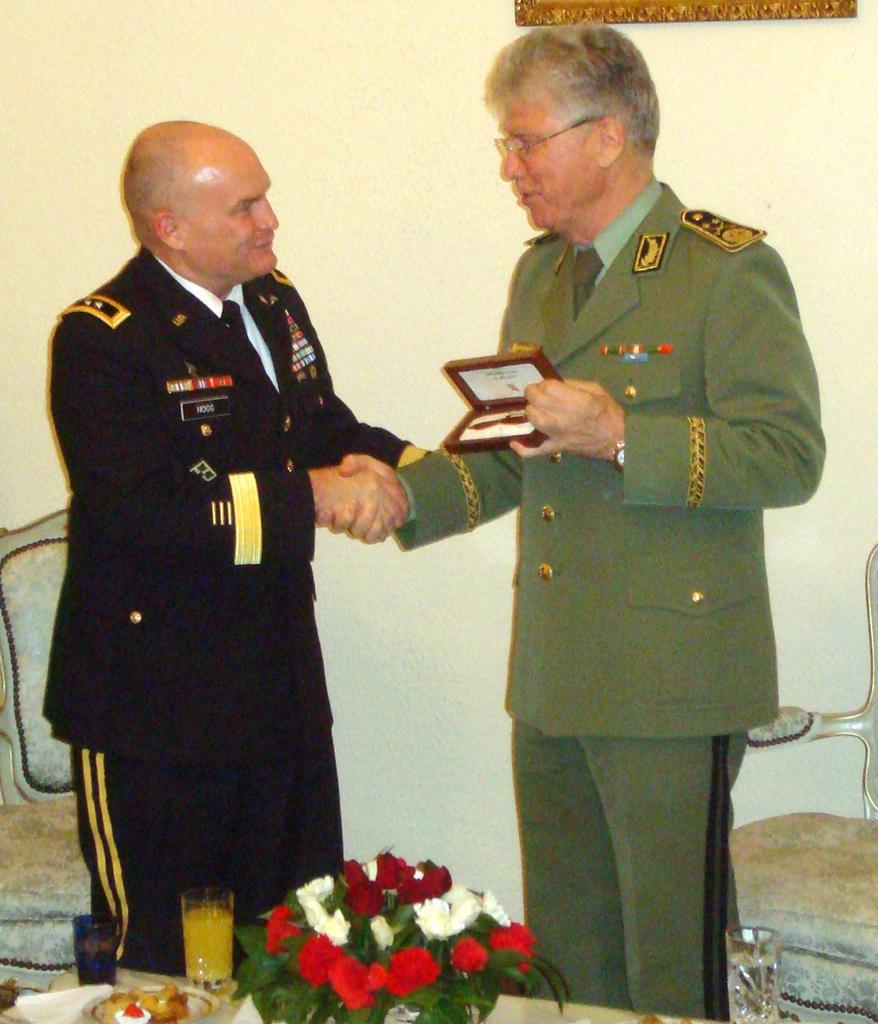Could you give a brief overview of what you see in this image? In this image I can see there are two persons and back side of them I can see two chairs and the wall and in front of them I can see a flower boo key and another glass contain a juice and plate contain a food , on the right side person he holding an object and wearing a spectacle. 